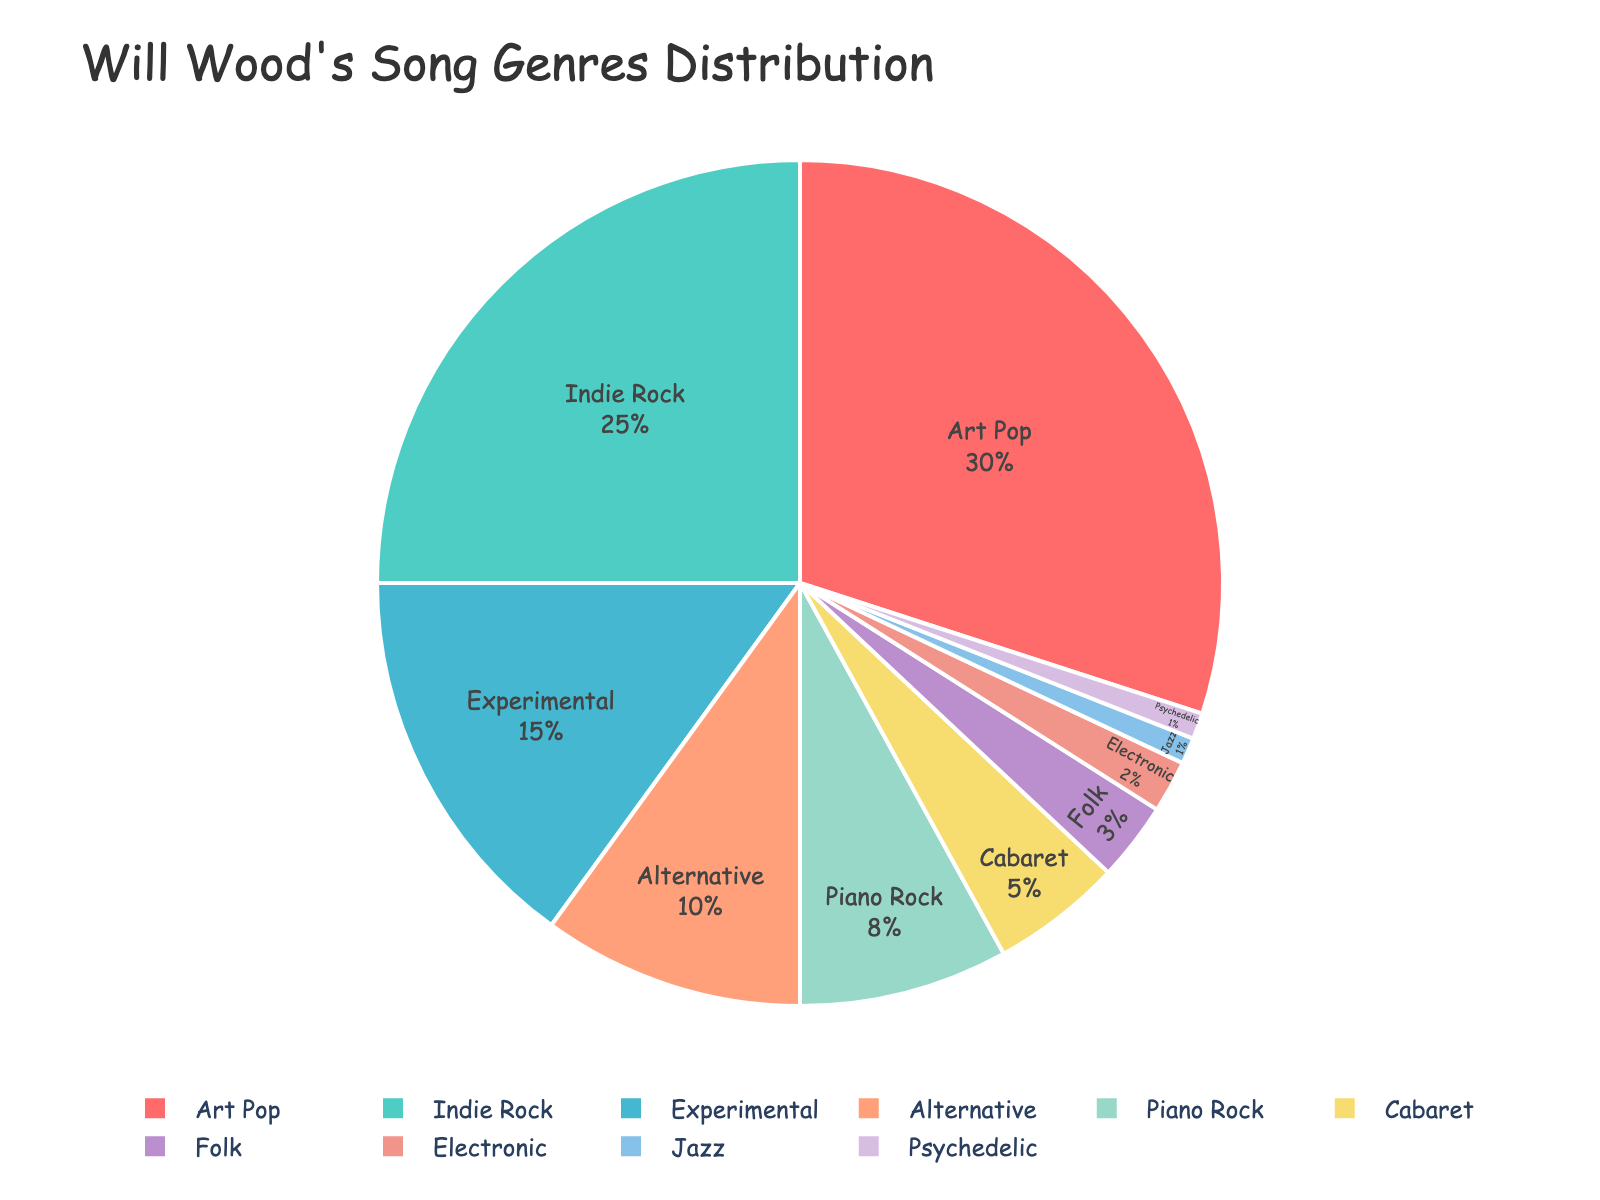What's the largest genre in Will Wood's song distribution? The largest genre is represented by the largest segment in the pie chart. From the chart, we see that "Art Pop" has the largest segment, which is 30%.
Answer: Art Pop Which genre occupies the smallest portion of the pie chart? The smallest portion in the pie chart is the smallest segment, which has a percentage of 1%. The genres listed with 1% are "Jazz" and "Psychedelic".
Answer: Jazz, Psychedelic How many genres have a higher percentage than "Piano Rock"? "Piano Rock" has a percentage of 8%. Counting the segments with a higher percentage, we find "Art Pop", "Indie Rock", and "Experimental". Therefore, three genres have a higher percentage than "Piano Rock".
Answer: 3 What's the combined percentage for "Folk" and "Electronic"? To find the combined percentage, we add the percentages for "Folk" (3%) and "Electronic" (2%). The total is 3% + 2% = 5%.
Answer: 5% Which genre is represented by the green segment in the pie chart? The green segment corresponds to "Indie Rock" as its color in the chart is green and its portion size shows around 25%.
Answer: Indie Rock How much larger is the portion of "Alternative" compared to "Jazz"? "Alternative" occupies 10%, while "Jazz" occupies 1%. The difference is 10% - 1% = 9%.
Answer: 9% Are there more genres with a percentage lower than "Alternative" or higher than "Alternative"? "Alternative" occupies 10%. Segments lower: "Piano Rock", "Cabaret", "Folk", "Electronic", "Jazz", and "Psychedelic" (6 genres). Segments higher: "Art Pop", "Indie Rock", "Experimental" (3 genres). There are more genres with a lower percentage.
Answer: More genres with a lower percentage Which genres together make up exactly half of the distribution? We need to find genres whose combined percentage equals 50%. "Art Pop" and "Indie Rock" together sum up to 30% + 25% = 55%, which is more than half. However, combining "Art Pop" (30%) and "Experimental" (15%) with "Alternative" (10%) gives 55%. Another combination might be impossible within the given percentages to sum to exactly 50%.
Answer: None What's the total percentage for genres classified as "less popular" (those that have 5% or less)? Adding the percentages for genres with 5% or less: "Cabaret" (5%), "Folk" (3%), "Electronic" (2%), "Jazz" (1%), and "Psychedelic" (1%). The total is 5% + 3% + 2% + 1% + 1% = 12%.
Answer: 12% Which genre has a percentage closest to the median value of all percentages shown? First, we list all percentages: 30, 25, 15, 10, 8, 5, 3, 2, 1, 1. With 10 values, the median is the average of the 5th and 6th values. Sorting, we get: 1, 1, 2, 3, 5, 8, 10, 15, 25, 30. The median is (5 + 8) / 2 = 6.5 which is closest to "Piano Rock" at 8%.
Answer: Piano Rock 